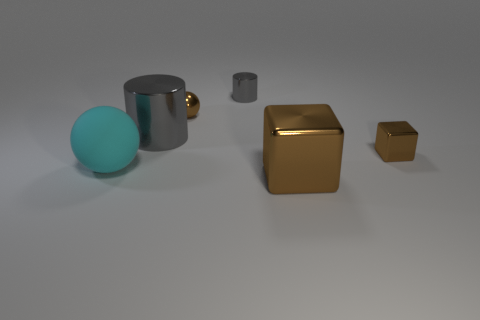Is the number of big gray cylinders in front of the small gray metal thing the same as the number of small gray shiny cylinders on the left side of the large gray metal thing?
Your response must be concise. No. Is the number of big green shiny balls greater than the number of brown shiny things?
Your response must be concise. No. How many metallic objects are either yellow things or large cylinders?
Provide a succinct answer. 1. What number of small metal balls are the same color as the small shiny cylinder?
Give a very brief answer. 0. There is a big object that is in front of the ball that is in front of the gray shiny cylinder to the left of the small gray metal object; what is its material?
Give a very brief answer. Metal. There is a big metallic cylinder that is behind the large object to the left of the large cylinder; what is its color?
Offer a terse response. Gray. How many small objects are shiny balls or cyan matte spheres?
Make the answer very short. 1. How many cyan spheres have the same material as the big gray cylinder?
Ensure brevity in your answer.  0. What is the size of the sphere on the right side of the big gray metal thing?
Your response must be concise. Small. There is a big metal object in front of the small metallic block on the right side of the cyan rubber ball; what shape is it?
Offer a very short reply. Cube. 